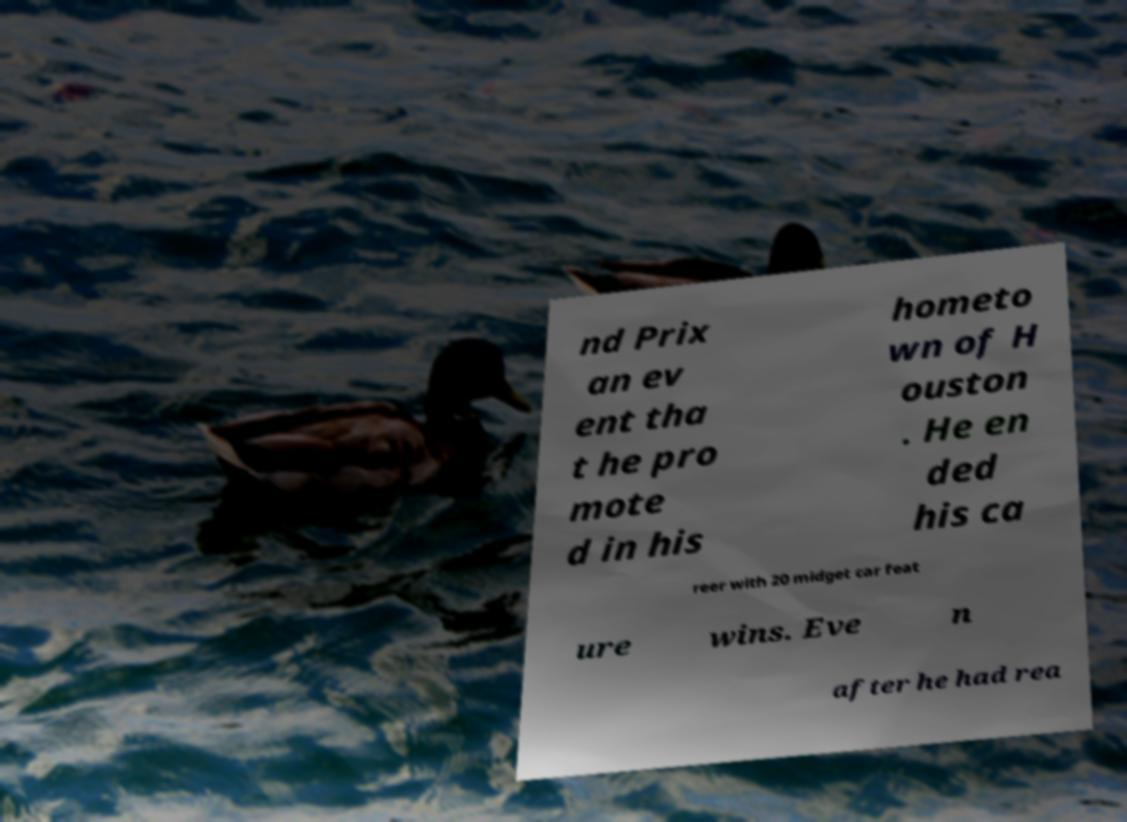Can you accurately transcribe the text from the provided image for me? nd Prix an ev ent tha t he pro mote d in his hometo wn of H ouston . He en ded his ca reer with 20 midget car feat ure wins. Eve n after he had rea 